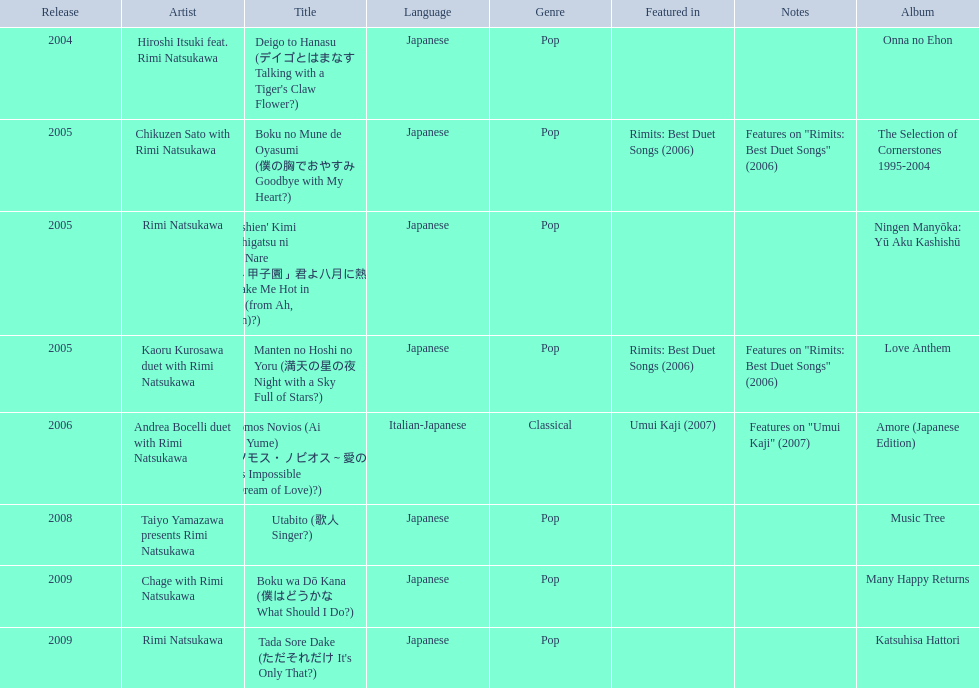What are the notes for sky full of stars? Features on "Rimits: Best Duet Songs" (2006). What other song features this same note? Boku no Mune de Oyasumi (僕の胸でおやすみ Goodbye with My Heart?). 